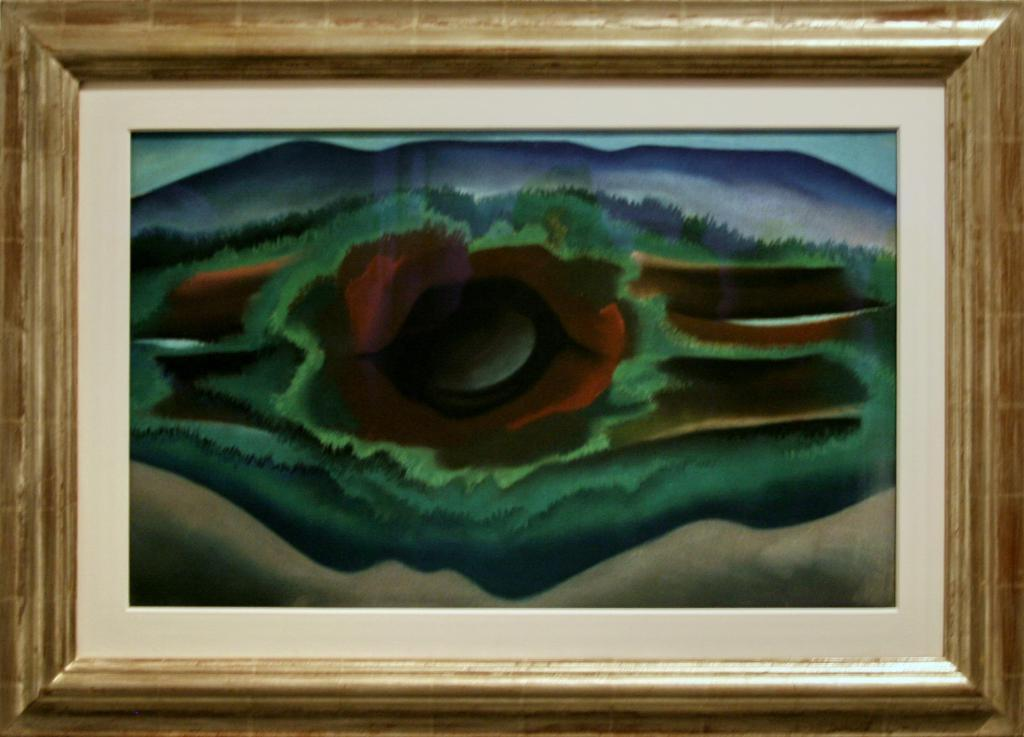What is the main subject of the image? The main subject of the image is a colorful frame. What colors can be seen in the frame? The frame contains blue, green, red, black, and brown colors. Is there a goat grazing in the frame? There is no goat present in the image. What season is depicted in the frame? The image does not depict a specific season, as it only shows a colorful frame. 